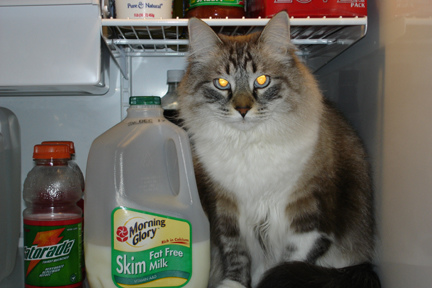Please identify all text content in this image. Morning Glory Glory Skim Fat Free torade 